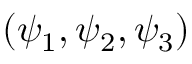Convert formula to latex. <formula><loc_0><loc_0><loc_500><loc_500>( \psi _ { 1 } , \psi _ { 2 } , \psi _ { 3 } )</formula> 